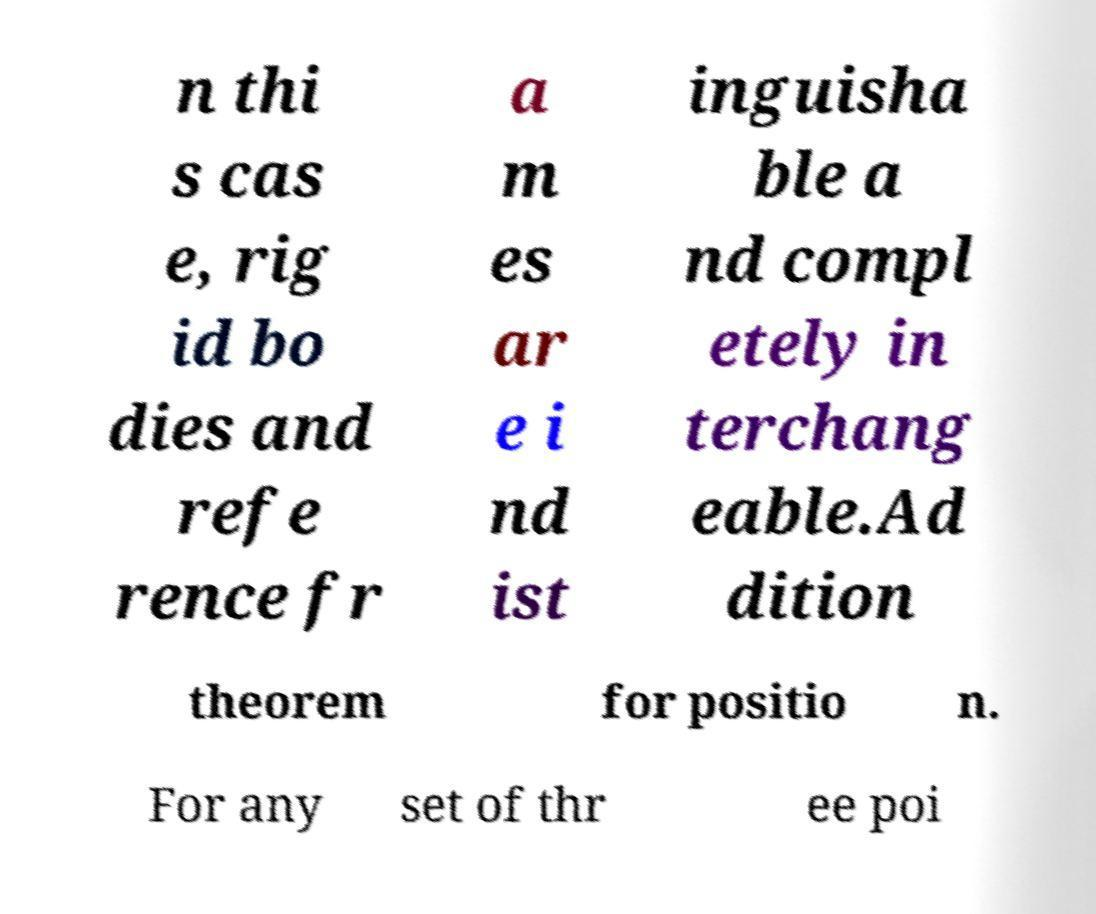Can you accurately transcribe the text from the provided image for me? n thi s cas e, rig id bo dies and refe rence fr a m es ar e i nd ist inguisha ble a nd compl etely in terchang eable.Ad dition theorem for positio n. For any set of thr ee poi 